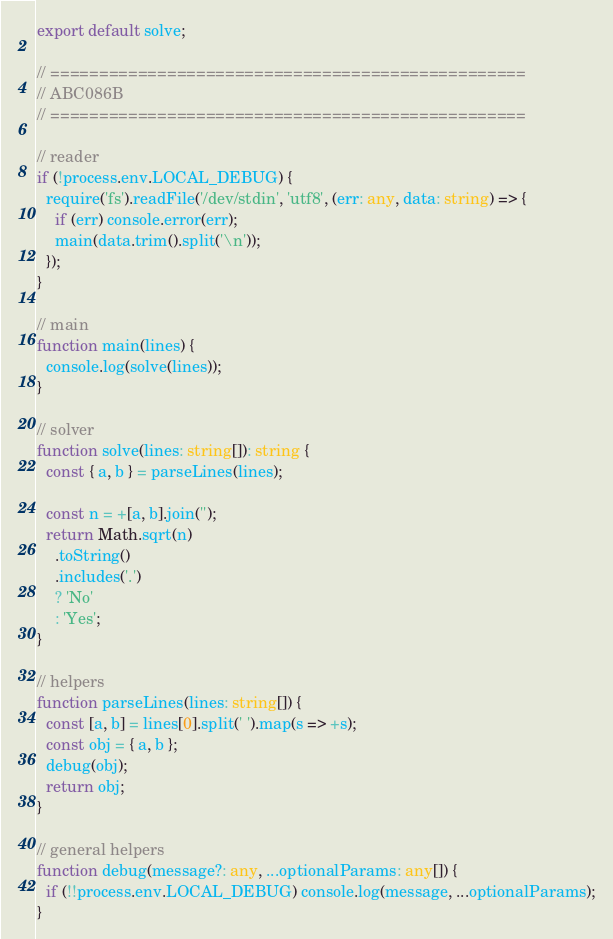Convert code to text. <code><loc_0><loc_0><loc_500><loc_500><_TypeScript_>export default solve;

// =================================================
// ABC086B
// =================================================

// reader
if (!process.env.LOCAL_DEBUG) {
  require('fs').readFile('/dev/stdin', 'utf8', (err: any, data: string) => {
    if (err) console.error(err);
    main(data.trim().split('\n'));
  });
}

// main
function main(lines) {
  console.log(solve(lines));
}

// solver
function solve(lines: string[]): string {
  const { a, b } = parseLines(lines);

  const n = +[a, b].join('');
  return Math.sqrt(n)
    .toString()
    .includes('.')
    ? 'No'
    : 'Yes';
}

// helpers
function parseLines(lines: string[]) {
  const [a, b] = lines[0].split(' ').map(s => +s);
  const obj = { a, b };
  debug(obj);
  return obj;
}

// general helpers
function debug(message?: any, ...optionalParams: any[]) {
  if (!!process.env.LOCAL_DEBUG) console.log(message, ...optionalParams);
}
</code> 